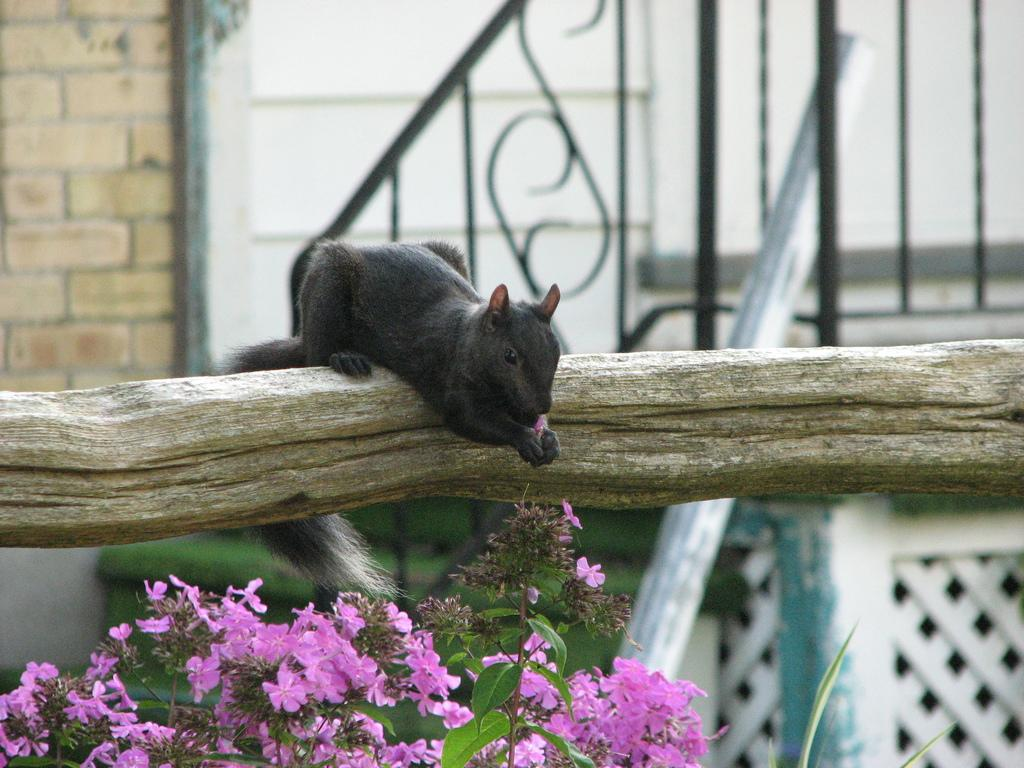What type of plant is at the bottom of the image? There is a plant with flowers at the bottom of the image. What part of a tree is visible in the image? There is tree bark in the image. What animal is in the middle of the image? There is a Tasmanian devil in the middle of the image. What can be seen in the background of the image? There is a wall and a railing in the background of the image. Can you see any veins on the Tasmanian devil in the image? There are no visible veins on the Tasmanian devil in the image, as it is not a human or a detailed illustration of the animal. What type of magic is being performed by the plant in the image? There is no magic being performed by the plant in the image; it is a natural plant with flowers. 